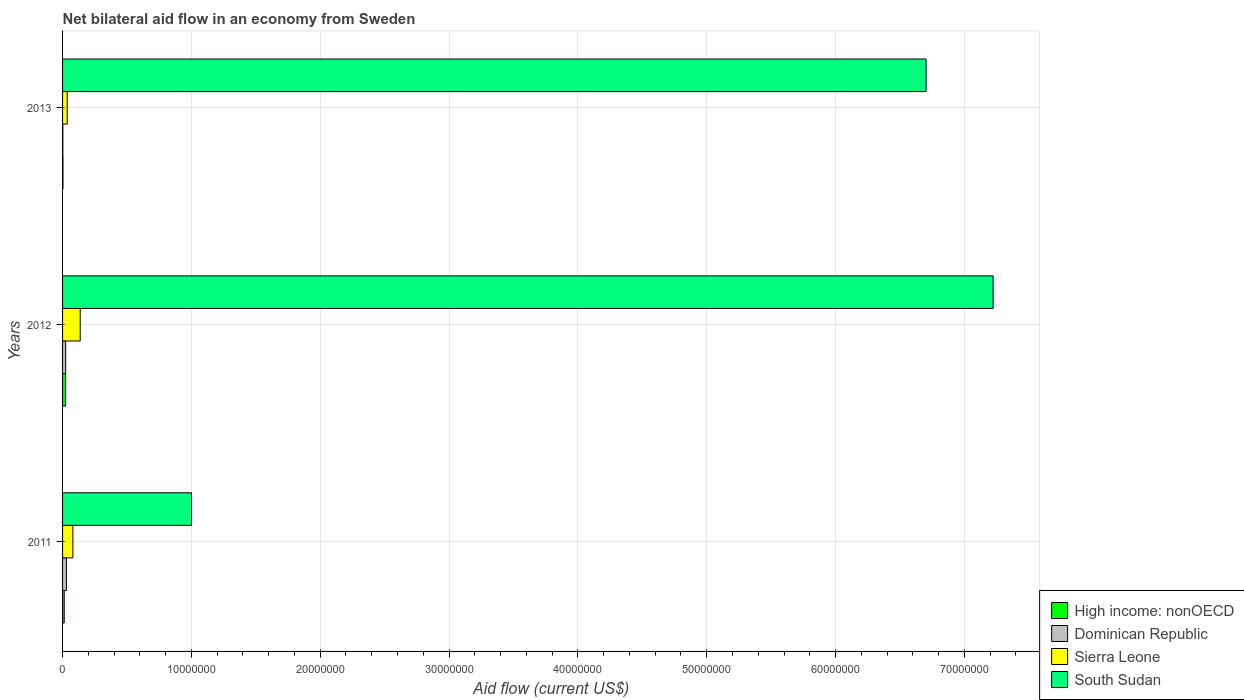How many groups of bars are there?
Provide a succinct answer. 3. Are the number of bars per tick equal to the number of legend labels?
Give a very brief answer. Yes. How many bars are there on the 3rd tick from the top?
Your answer should be compact. 4. What is the net bilateral aid flow in Dominican Republic in 2012?
Offer a terse response. 2.40e+05. Across all years, what is the maximum net bilateral aid flow in South Sudan?
Give a very brief answer. 7.22e+07. Across all years, what is the minimum net bilateral aid flow in High income: nonOECD?
Your answer should be very brief. 3.00e+04. In which year was the net bilateral aid flow in South Sudan maximum?
Make the answer very short. 2012. What is the total net bilateral aid flow in Sierra Leone in the graph?
Your answer should be compact. 2.53e+06. What is the difference between the net bilateral aid flow in South Sudan in 2013 and the net bilateral aid flow in Sierra Leone in 2012?
Ensure brevity in your answer.  6.57e+07. What is the average net bilateral aid flow in Dominican Republic per year?
Give a very brief answer. 1.87e+05. In the year 2013, what is the difference between the net bilateral aid flow in South Sudan and net bilateral aid flow in Sierra Leone?
Your answer should be compact. 6.67e+07. In how many years, is the net bilateral aid flow in South Sudan greater than 66000000 US$?
Your response must be concise. 2. What is the ratio of the net bilateral aid flow in South Sudan in 2011 to that in 2012?
Provide a succinct answer. 0.14. Is the net bilateral aid flow in Sierra Leone in 2011 less than that in 2012?
Provide a succinct answer. Yes. What is the difference between the highest and the second highest net bilateral aid flow in Dominican Republic?
Offer a terse response. 6.00e+04. What is the difference between the highest and the lowest net bilateral aid flow in South Sudan?
Make the answer very short. 6.22e+07. Is the sum of the net bilateral aid flow in High income: nonOECD in 2012 and 2013 greater than the maximum net bilateral aid flow in Sierra Leone across all years?
Make the answer very short. No. What does the 4th bar from the top in 2012 represents?
Your response must be concise. High income: nonOECD. What does the 2nd bar from the bottom in 2011 represents?
Keep it short and to the point. Dominican Republic. Is it the case that in every year, the sum of the net bilateral aid flow in South Sudan and net bilateral aid flow in High income: nonOECD is greater than the net bilateral aid flow in Dominican Republic?
Your response must be concise. Yes. How many bars are there?
Your answer should be compact. 12. Are all the bars in the graph horizontal?
Provide a succinct answer. Yes. How many years are there in the graph?
Keep it short and to the point. 3. What is the difference between two consecutive major ticks on the X-axis?
Provide a short and direct response. 1.00e+07. Does the graph contain grids?
Make the answer very short. Yes. How many legend labels are there?
Your answer should be very brief. 4. What is the title of the graph?
Your answer should be compact. Net bilateral aid flow in an economy from Sweden. Does "Ecuador" appear as one of the legend labels in the graph?
Your answer should be compact. No. What is the Aid flow (current US$) in High income: nonOECD in 2011?
Your answer should be very brief. 1.30e+05. What is the Aid flow (current US$) of Sierra Leone in 2011?
Offer a terse response. 8.00e+05. What is the Aid flow (current US$) of South Sudan in 2011?
Provide a succinct answer. 1.00e+07. What is the Aid flow (current US$) in Sierra Leone in 2012?
Offer a terse response. 1.37e+06. What is the Aid flow (current US$) of South Sudan in 2012?
Keep it short and to the point. 7.22e+07. What is the Aid flow (current US$) in High income: nonOECD in 2013?
Provide a succinct answer. 3.00e+04. What is the Aid flow (current US$) in South Sudan in 2013?
Provide a succinct answer. 6.70e+07. Across all years, what is the maximum Aid flow (current US$) of Dominican Republic?
Ensure brevity in your answer.  3.00e+05. Across all years, what is the maximum Aid flow (current US$) in Sierra Leone?
Give a very brief answer. 1.37e+06. Across all years, what is the maximum Aid flow (current US$) in South Sudan?
Provide a succinct answer. 7.22e+07. Across all years, what is the minimum Aid flow (current US$) of Dominican Republic?
Offer a very short reply. 2.00e+04. Across all years, what is the minimum Aid flow (current US$) of Sierra Leone?
Provide a succinct answer. 3.60e+05. Across all years, what is the minimum Aid flow (current US$) in South Sudan?
Give a very brief answer. 1.00e+07. What is the total Aid flow (current US$) in Dominican Republic in the graph?
Your answer should be very brief. 5.60e+05. What is the total Aid flow (current US$) in Sierra Leone in the graph?
Provide a short and direct response. 2.53e+06. What is the total Aid flow (current US$) in South Sudan in the graph?
Offer a terse response. 1.49e+08. What is the difference between the Aid flow (current US$) of Sierra Leone in 2011 and that in 2012?
Make the answer very short. -5.70e+05. What is the difference between the Aid flow (current US$) of South Sudan in 2011 and that in 2012?
Provide a short and direct response. -6.22e+07. What is the difference between the Aid flow (current US$) in Dominican Republic in 2011 and that in 2013?
Provide a succinct answer. 2.80e+05. What is the difference between the Aid flow (current US$) of Sierra Leone in 2011 and that in 2013?
Provide a short and direct response. 4.40e+05. What is the difference between the Aid flow (current US$) of South Sudan in 2011 and that in 2013?
Offer a very short reply. -5.70e+07. What is the difference between the Aid flow (current US$) in Dominican Republic in 2012 and that in 2013?
Provide a short and direct response. 2.20e+05. What is the difference between the Aid flow (current US$) in Sierra Leone in 2012 and that in 2013?
Offer a very short reply. 1.01e+06. What is the difference between the Aid flow (current US$) in South Sudan in 2012 and that in 2013?
Your answer should be very brief. 5.20e+06. What is the difference between the Aid flow (current US$) in High income: nonOECD in 2011 and the Aid flow (current US$) in Sierra Leone in 2012?
Your response must be concise. -1.24e+06. What is the difference between the Aid flow (current US$) of High income: nonOECD in 2011 and the Aid flow (current US$) of South Sudan in 2012?
Provide a succinct answer. -7.21e+07. What is the difference between the Aid flow (current US$) in Dominican Republic in 2011 and the Aid flow (current US$) in Sierra Leone in 2012?
Ensure brevity in your answer.  -1.07e+06. What is the difference between the Aid flow (current US$) in Dominican Republic in 2011 and the Aid flow (current US$) in South Sudan in 2012?
Ensure brevity in your answer.  -7.19e+07. What is the difference between the Aid flow (current US$) of Sierra Leone in 2011 and the Aid flow (current US$) of South Sudan in 2012?
Provide a short and direct response. -7.14e+07. What is the difference between the Aid flow (current US$) in High income: nonOECD in 2011 and the Aid flow (current US$) in Dominican Republic in 2013?
Ensure brevity in your answer.  1.10e+05. What is the difference between the Aid flow (current US$) in High income: nonOECD in 2011 and the Aid flow (current US$) in South Sudan in 2013?
Offer a very short reply. -6.69e+07. What is the difference between the Aid flow (current US$) of Dominican Republic in 2011 and the Aid flow (current US$) of South Sudan in 2013?
Give a very brief answer. -6.67e+07. What is the difference between the Aid flow (current US$) of Sierra Leone in 2011 and the Aid flow (current US$) of South Sudan in 2013?
Your answer should be very brief. -6.62e+07. What is the difference between the Aid flow (current US$) in High income: nonOECD in 2012 and the Aid flow (current US$) in South Sudan in 2013?
Ensure brevity in your answer.  -6.68e+07. What is the difference between the Aid flow (current US$) in Dominican Republic in 2012 and the Aid flow (current US$) in Sierra Leone in 2013?
Provide a succinct answer. -1.20e+05. What is the difference between the Aid flow (current US$) in Dominican Republic in 2012 and the Aid flow (current US$) in South Sudan in 2013?
Your answer should be compact. -6.68e+07. What is the difference between the Aid flow (current US$) of Sierra Leone in 2012 and the Aid flow (current US$) of South Sudan in 2013?
Your answer should be very brief. -6.57e+07. What is the average Aid flow (current US$) in High income: nonOECD per year?
Your response must be concise. 1.33e+05. What is the average Aid flow (current US$) of Dominican Republic per year?
Keep it short and to the point. 1.87e+05. What is the average Aid flow (current US$) of Sierra Leone per year?
Provide a short and direct response. 8.43e+05. What is the average Aid flow (current US$) of South Sudan per year?
Make the answer very short. 4.98e+07. In the year 2011, what is the difference between the Aid flow (current US$) of High income: nonOECD and Aid flow (current US$) of Sierra Leone?
Provide a short and direct response. -6.70e+05. In the year 2011, what is the difference between the Aid flow (current US$) in High income: nonOECD and Aid flow (current US$) in South Sudan?
Your response must be concise. -9.88e+06. In the year 2011, what is the difference between the Aid flow (current US$) of Dominican Republic and Aid flow (current US$) of Sierra Leone?
Your response must be concise. -5.00e+05. In the year 2011, what is the difference between the Aid flow (current US$) of Dominican Republic and Aid flow (current US$) of South Sudan?
Give a very brief answer. -9.71e+06. In the year 2011, what is the difference between the Aid flow (current US$) in Sierra Leone and Aid flow (current US$) in South Sudan?
Your response must be concise. -9.21e+06. In the year 2012, what is the difference between the Aid flow (current US$) in High income: nonOECD and Aid flow (current US$) in Dominican Republic?
Offer a very short reply. 0. In the year 2012, what is the difference between the Aid flow (current US$) in High income: nonOECD and Aid flow (current US$) in Sierra Leone?
Provide a short and direct response. -1.13e+06. In the year 2012, what is the difference between the Aid flow (current US$) in High income: nonOECD and Aid flow (current US$) in South Sudan?
Offer a very short reply. -7.20e+07. In the year 2012, what is the difference between the Aid flow (current US$) of Dominican Republic and Aid flow (current US$) of Sierra Leone?
Provide a succinct answer. -1.13e+06. In the year 2012, what is the difference between the Aid flow (current US$) in Dominican Republic and Aid flow (current US$) in South Sudan?
Ensure brevity in your answer.  -7.20e+07. In the year 2012, what is the difference between the Aid flow (current US$) in Sierra Leone and Aid flow (current US$) in South Sudan?
Your answer should be very brief. -7.09e+07. In the year 2013, what is the difference between the Aid flow (current US$) of High income: nonOECD and Aid flow (current US$) of Dominican Republic?
Keep it short and to the point. 10000. In the year 2013, what is the difference between the Aid flow (current US$) of High income: nonOECD and Aid flow (current US$) of Sierra Leone?
Give a very brief answer. -3.30e+05. In the year 2013, what is the difference between the Aid flow (current US$) of High income: nonOECD and Aid flow (current US$) of South Sudan?
Provide a succinct answer. -6.70e+07. In the year 2013, what is the difference between the Aid flow (current US$) of Dominican Republic and Aid flow (current US$) of Sierra Leone?
Offer a terse response. -3.40e+05. In the year 2013, what is the difference between the Aid flow (current US$) in Dominican Republic and Aid flow (current US$) in South Sudan?
Keep it short and to the point. -6.70e+07. In the year 2013, what is the difference between the Aid flow (current US$) in Sierra Leone and Aid flow (current US$) in South Sudan?
Ensure brevity in your answer.  -6.67e+07. What is the ratio of the Aid flow (current US$) in High income: nonOECD in 2011 to that in 2012?
Keep it short and to the point. 0.54. What is the ratio of the Aid flow (current US$) in Dominican Republic in 2011 to that in 2012?
Your answer should be compact. 1.25. What is the ratio of the Aid flow (current US$) of Sierra Leone in 2011 to that in 2012?
Your answer should be compact. 0.58. What is the ratio of the Aid flow (current US$) in South Sudan in 2011 to that in 2012?
Your response must be concise. 0.14. What is the ratio of the Aid flow (current US$) of High income: nonOECD in 2011 to that in 2013?
Give a very brief answer. 4.33. What is the ratio of the Aid flow (current US$) of Sierra Leone in 2011 to that in 2013?
Offer a terse response. 2.22. What is the ratio of the Aid flow (current US$) in South Sudan in 2011 to that in 2013?
Your answer should be compact. 0.15. What is the ratio of the Aid flow (current US$) of Sierra Leone in 2012 to that in 2013?
Keep it short and to the point. 3.81. What is the ratio of the Aid flow (current US$) in South Sudan in 2012 to that in 2013?
Provide a short and direct response. 1.08. What is the difference between the highest and the second highest Aid flow (current US$) in Dominican Republic?
Provide a succinct answer. 6.00e+04. What is the difference between the highest and the second highest Aid flow (current US$) in Sierra Leone?
Make the answer very short. 5.70e+05. What is the difference between the highest and the second highest Aid flow (current US$) in South Sudan?
Offer a very short reply. 5.20e+06. What is the difference between the highest and the lowest Aid flow (current US$) of High income: nonOECD?
Ensure brevity in your answer.  2.10e+05. What is the difference between the highest and the lowest Aid flow (current US$) of Sierra Leone?
Ensure brevity in your answer.  1.01e+06. What is the difference between the highest and the lowest Aid flow (current US$) of South Sudan?
Your response must be concise. 6.22e+07. 